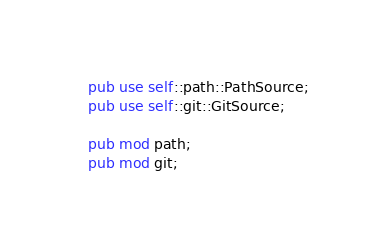<code> <loc_0><loc_0><loc_500><loc_500><_Rust_>pub use self::path::PathSource;
pub use self::git::GitSource;

pub mod path;
pub mod git;
</code> 